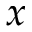<formula> <loc_0><loc_0><loc_500><loc_500>x</formula> 